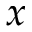<formula> <loc_0><loc_0><loc_500><loc_500>x</formula> 